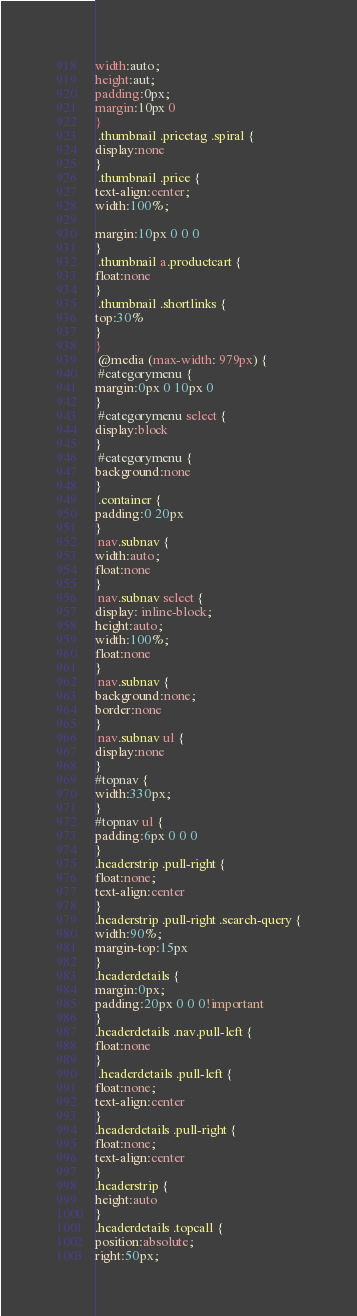<code> <loc_0><loc_0><loc_500><loc_500><_CSS_>width:auto;
height:aut;
padding:0px;
margin:10px 0
}
 .thumbnail .pricetag .spiral {
display:none
}
 .thumbnail .price {
text-align:center;
width:100%;

margin:10px 0 0 0
}
 .thumbnail a.productcart {
float:none
}
 .thumbnail .shortlinks {
top:30%
}
}
 @media (max-width: 979px) {
 #categorymenu {
margin:0px 0 10px 0
}
 #categorymenu select {
display:block
}
 #categorymenu {
background:none
}
 .container {
padding:0 20px
}
 nav.subnav {
width:auto;
float:none
}
 nav.subnav select {
display: inline-block;
height:auto;
width:100%;
float:none
}
 nav.subnav {
background:none;
border:none
}
 nav.subnav ul {
display:none
}
#topnav {
width:330px;
}
#topnav ul {
padding:6px 0 0 0
}
.headerstrip .pull-right {
float:none;
text-align:center
}
.headerstrip .pull-right .search-query {
width:90%;
margin-top:15px
}
.headerdetails {
margin:0px;
padding:20px 0 0 0!important
}
.headerdetails .nav.pull-left {
float:none
}
 .headerdetails .pull-left {
float:none;
text-align:center
}
.headerdetails .pull-right {
float:none;
text-align:center
}
.headerstrip {
height:auto
}
.headerdetails .topcall {
position:absolute;
right:50px;</code> 